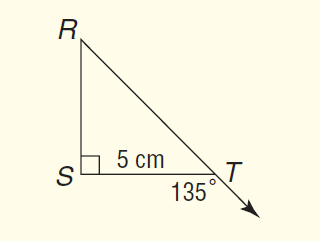Question: What is the length of R T?
Choices:
A. 5
B. 5 \sqrt { 2 }
C. 5 \sqrt { 3 }
D. 10
Answer with the letter. Answer: B 